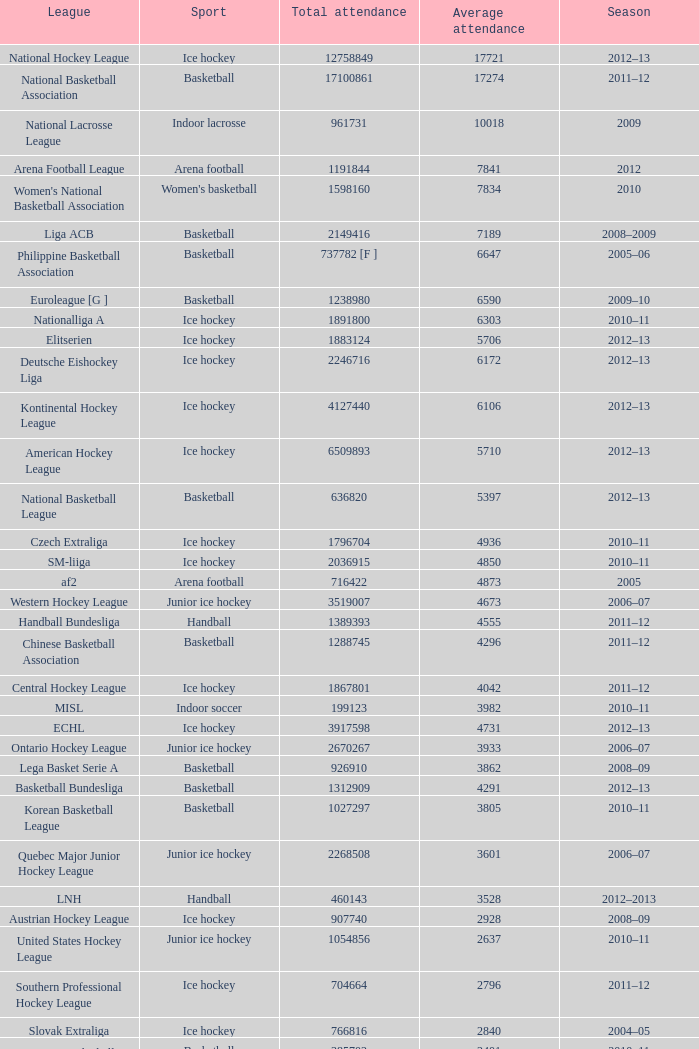What's the total attendance in rink hockey when the average attendance was smaller than 4850? 115000.0. 